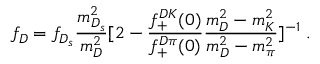<formula> <loc_0><loc_0><loc_500><loc_500>f _ { D } = f _ { D _ { s } } \frac { m _ { D _ { s } } ^ { 2 } } { m _ { D } ^ { 2 } } [ 2 - \frac { f _ { + } ^ { D K } ( 0 ) } { f _ { + } ^ { D \pi } ( 0 ) } \frac { m _ { D } ^ { 2 } - m _ { K } ^ { 2 } } { m _ { D } ^ { 2 } - m _ { \pi } ^ { 2 } } ] ^ { - 1 } \, .</formula> 